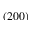<formula> <loc_0><loc_0><loc_500><loc_500>( 2 0 0 )</formula> 